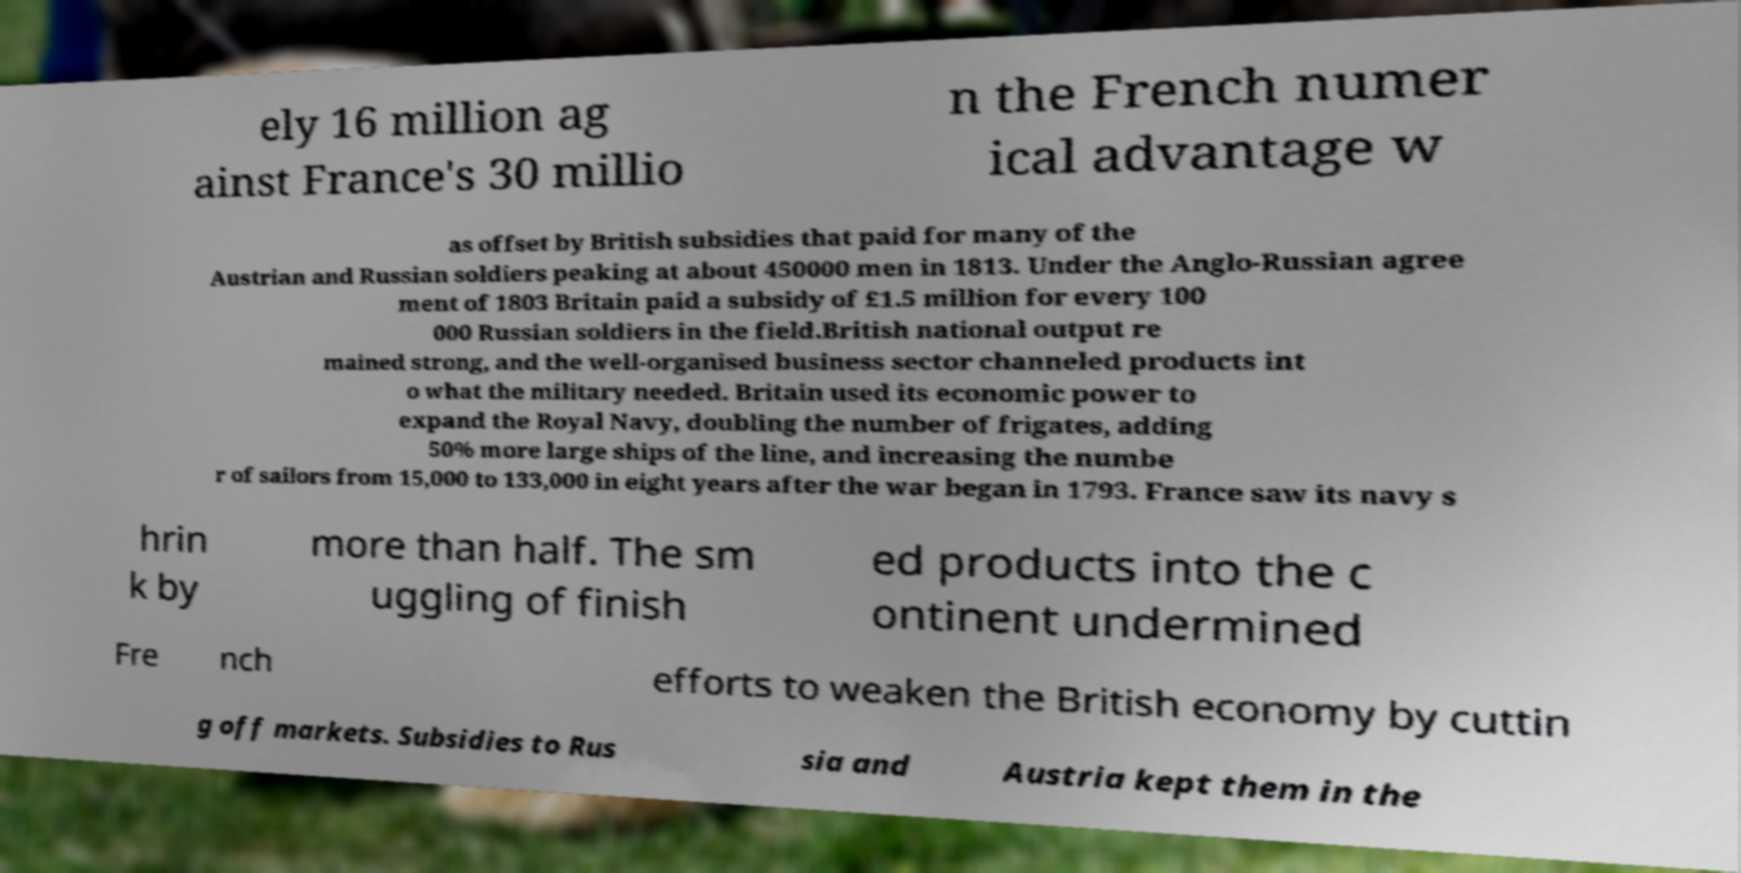Can you accurately transcribe the text from the provided image for me? ely 16 million ag ainst France's 30 millio n the French numer ical advantage w as offset by British subsidies that paid for many of the Austrian and Russian soldiers peaking at about 450000 men in 1813. Under the Anglo-Russian agree ment of 1803 Britain paid a subsidy of £1.5 million for every 100 000 Russian soldiers in the field.British national output re mained strong, and the well-organised business sector channeled products int o what the military needed. Britain used its economic power to expand the Royal Navy, doubling the number of frigates, adding 50% more large ships of the line, and increasing the numbe r of sailors from 15,000 to 133,000 in eight years after the war began in 1793. France saw its navy s hrin k by more than half. The sm uggling of finish ed products into the c ontinent undermined Fre nch efforts to weaken the British economy by cuttin g off markets. Subsidies to Rus sia and Austria kept them in the 